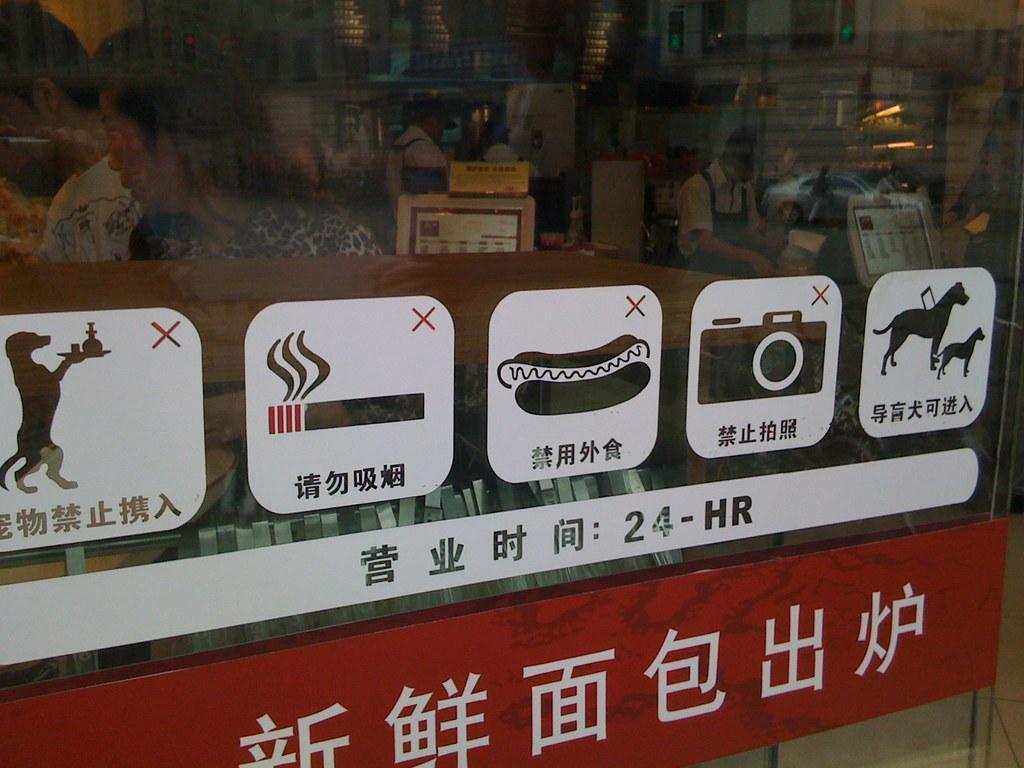Describe this image in one or two sentences. On this there are stickers. Through this glass we can see people and screens. On this glass there is a reflection of car and a person. 